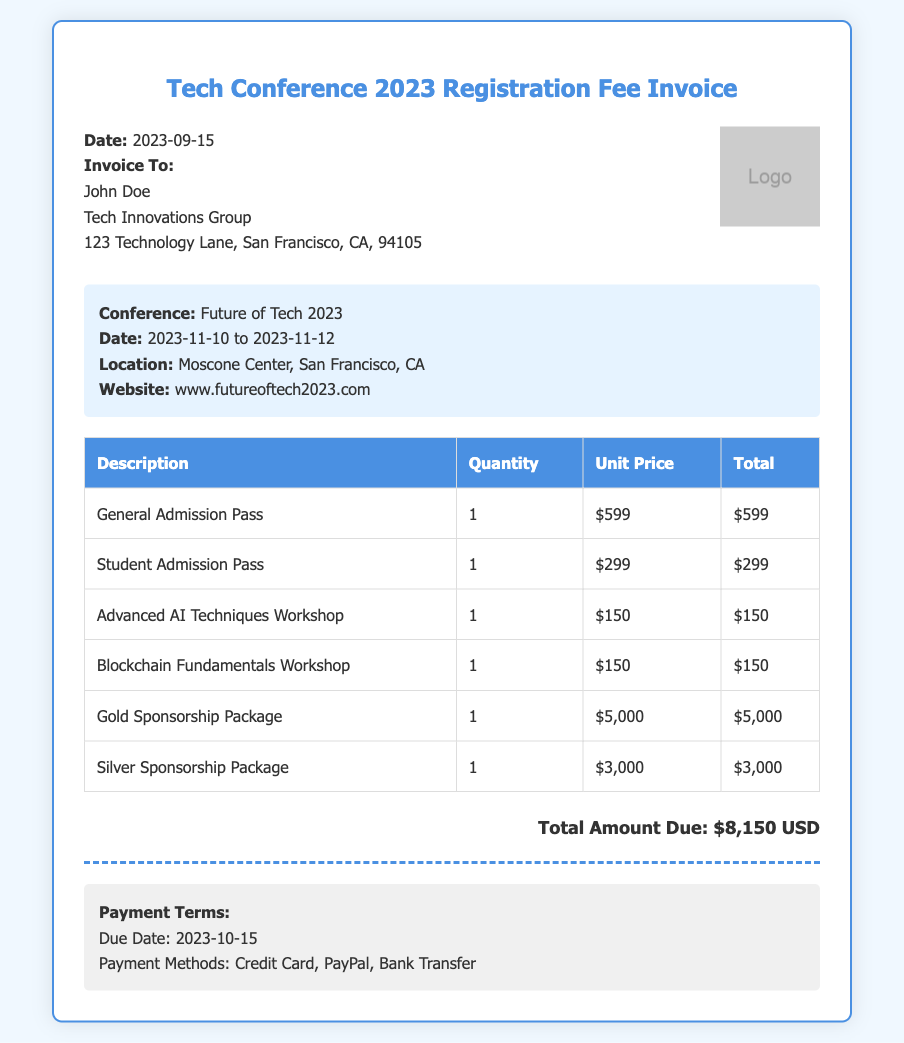What is the invoice date? The invoice date is stated in the document and is specifically provided as 2023-09-15.
Answer: 2023-09-15 Who is the invoice addressed to? The document specifies to whom the invoice is addressed, in this case, it is John Doe.
Answer: John Doe What is the total amount due? The total amount due is clearly stated in the document after the itemized list, which sums up to $8,150 USD.
Answer: $8,150 USD What is the price of the Gold Sponsorship Package? The document includes prices for packages, with the Gold Sponsorship Package listed as $5,000.
Answer: $5,000 How many workshops are included in the invoice? The invoice shows two workshops listed in the table under workshop costs.
Answer: 2 What payment methods are mentioned? The document outlines various payment methods provided, which include Credit Card, PayPal, and Bank Transfer.
Answer: Credit Card, PayPal, Bank Transfer What is the due date for payment? The due date for payment is specified in the payment terms section of the document, which is 2023-10-15.
Answer: 2023-10-15 What is the location of the conference? The document provides the conference location, mentioned as Moscone Center, San Francisco, CA.
Answer: Moscone Center, San Francisco, CA What is the cost of the Student Admission Pass? The cost for the Student Admission Pass is outlined in the document as $299.
Answer: $299 